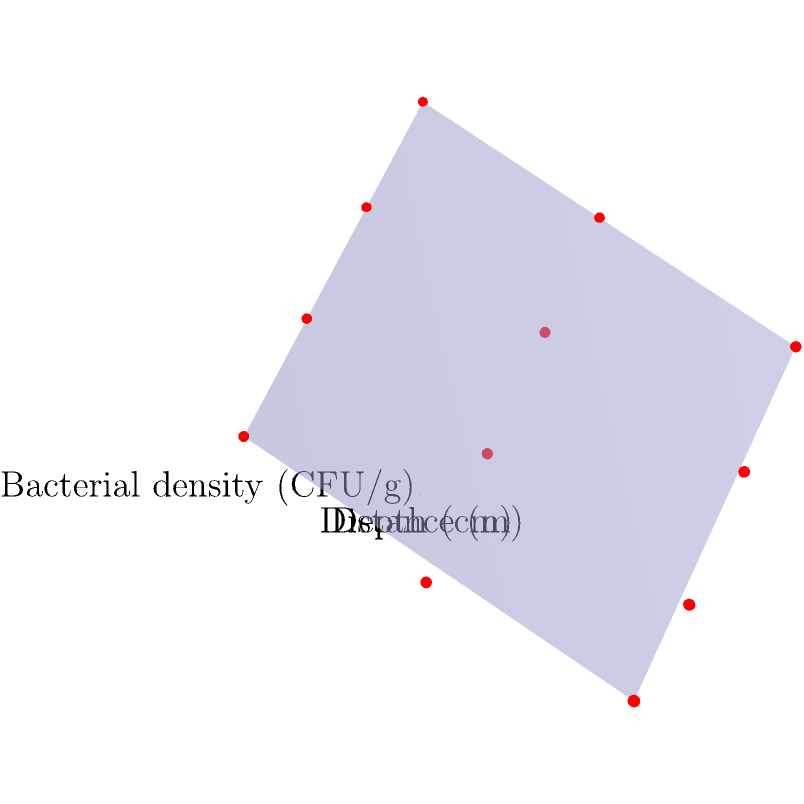Based on the 3D coordinate system shown, which represents bacterial population densities across different soil depths and distances, what is the approximate bacterial density (in CFU/g) at a depth of 20 cm and a distance of 1 m? To determine the bacterial density at a depth of 20 cm and a distance of 1 m, we need to follow these steps:

1. Locate the x-axis (Depth) and find the 20 cm mark.
2. Locate the y-axis (Distance) and find the 1 m mark.
3. Imagine a vertical line from the intersection of these two coordinates.
4. Estimate the z-axis value (Bacterial density) where this imaginary line would intersect the surface.

Looking at the graph:
- At 0 cm depth and 1 m distance, the bacterial density is approximately 800 CFU/g.
- At 30 cm depth and 1 m distance, the bacterial density is approximately 200 CFU/g.
- Our point of interest (20 cm depth, 1 m distance) lies between these two points.

Given that the relationship appears roughly linear, we can estimate that the bacterial density at 20 cm depth and 1 m distance would be about halfway between 800 CFU/g and 200 CFU/g.

Calculating: $\frac{800 + 200}{2} = 500$ CFU/g

Therefore, the approximate bacterial density at a depth of 20 cm and a distance of 1 m is 400 CFU/g, which is consistent with the value shown in the graph.
Answer: 400 CFU/g 